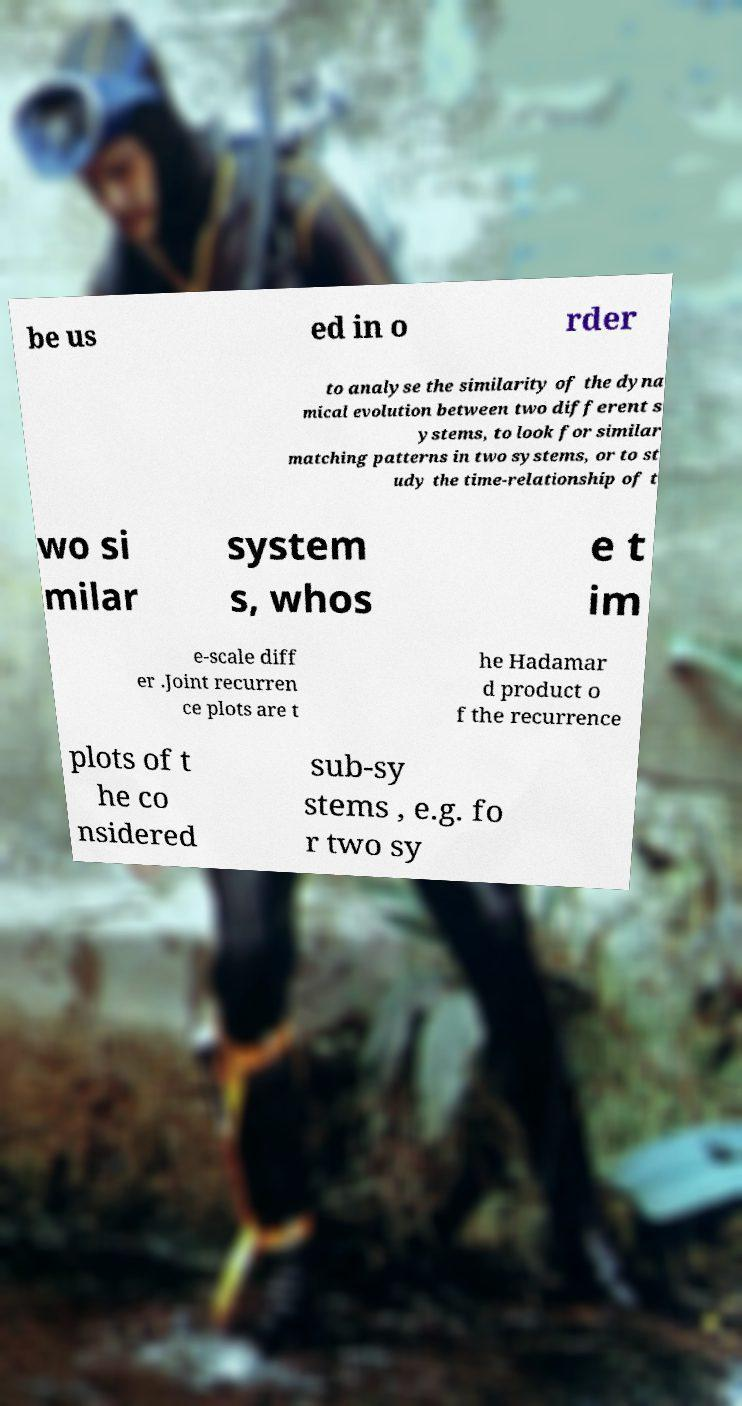There's text embedded in this image that I need extracted. Can you transcribe it verbatim? be us ed in o rder to analyse the similarity of the dyna mical evolution between two different s ystems, to look for similar matching patterns in two systems, or to st udy the time-relationship of t wo si milar system s, whos e t im e-scale diff er .Joint recurren ce plots are t he Hadamar d product o f the recurrence plots of t he co nsidered sub-sy stems , e.g. fo r two sy 